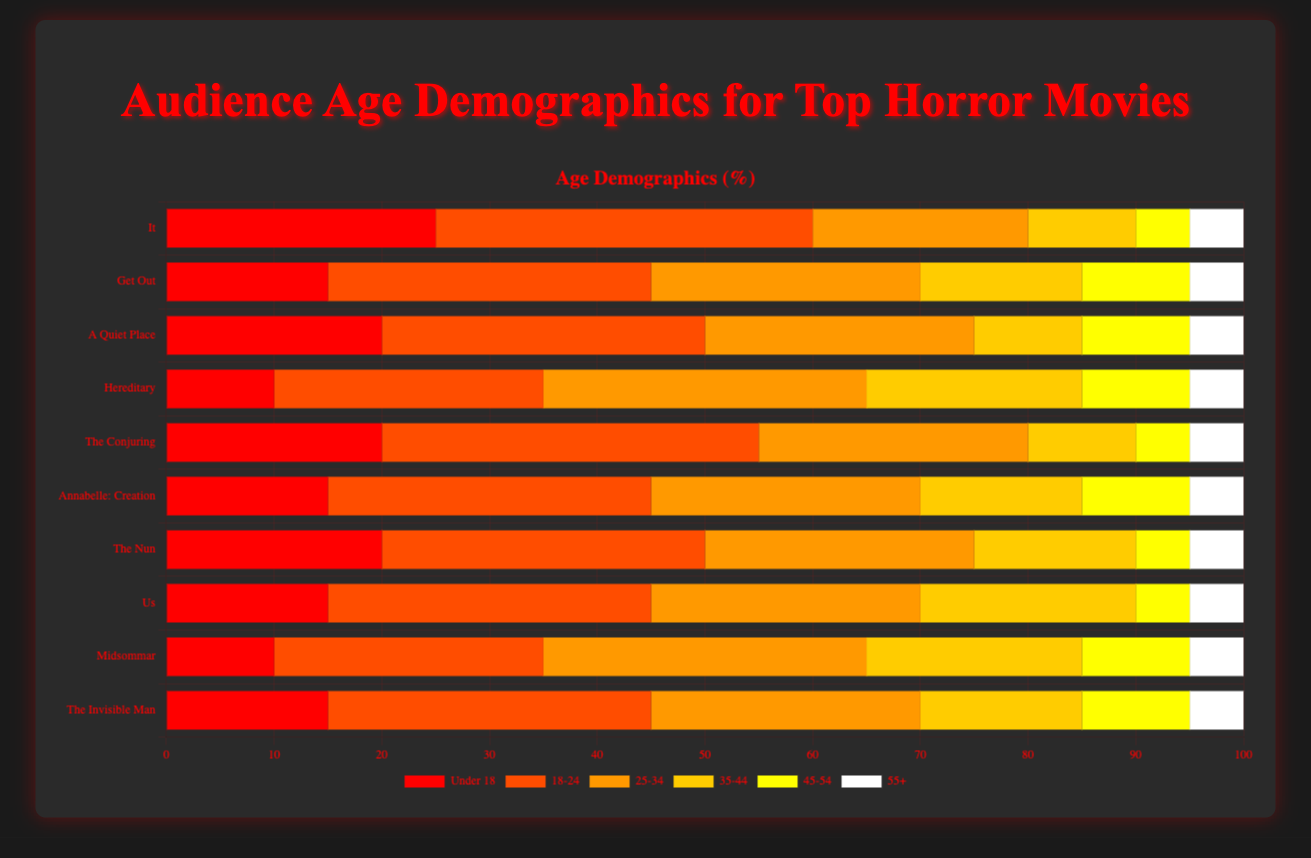Which movie has the highest percentage of viewers under 18? Looking at the grouped bars for the 'Under 18' age group, the bar for "It" is the highest.
Answer: It Which movie has the lowest percentage of viewers aged 35-44? Reviewing the grouped bars for the '35-44' age group, the bar for "It"' is the shortest.
Answer: It Compare the percentage of viewers aged 18-24 for "It" and "The Conjuring". Which has a higher percentage? By comparing the '18-24' bars for both movies, "It" and "The Conjuring", both bars have equal height.
Answer: Equal What is the combined percentage of viewers aged 45-54 and 55+ for "A Quiet Place"? Adding the values of the '45-54' and '55+' bars for "A Quiet Place" gives 10% + 5% = 15%.
Answer: 15% Are there any movies where the percentage of viewers aged 55+ is greater than 10%? Scanning all the bars for the '55+' age group, none of the movies have a bar higher than 5%.
Answer: No What is the average percentage of viewers aged 25-34 across all movies? Summing the '25-34' values (20+25+25+30+25+25+25+25+30+25) gives 255, then dividing by 10 movies results in an average of 255/10 = 25.5%.
Answer: 25.5% For the movie "Midsommar", what is the difference between the percentage of viewers aged Under 18 and those aged 25-34? The 'Under 18' bar for "Midsommar" is 10% and the '25-34' bar is 30%, so the difference is 30% - 10% = 20%.
Answer: 20% Which age group consistently has the lowest percentage of viewers across all movies? Checking all the grouped bars, the '55+' age group consistently has the shortest bars for each movie.
Answer: 55+ How does the percentage of viewers aged 18-24 for "Us" compare to "Annabelle: Creation"? Observing the '18-24' bars for "Us" and "Annabelle: Creation" shows they are equal in height.
Answer: Equal What's the median percentage of viewers aged 25-34 across all movies? Arranging the '25-34' percentages (20, 25, 25, 25, 25, 25, 25, 25, 30, 30) in ascending order, the median (middle value) is 25%.
Answer: 25% 